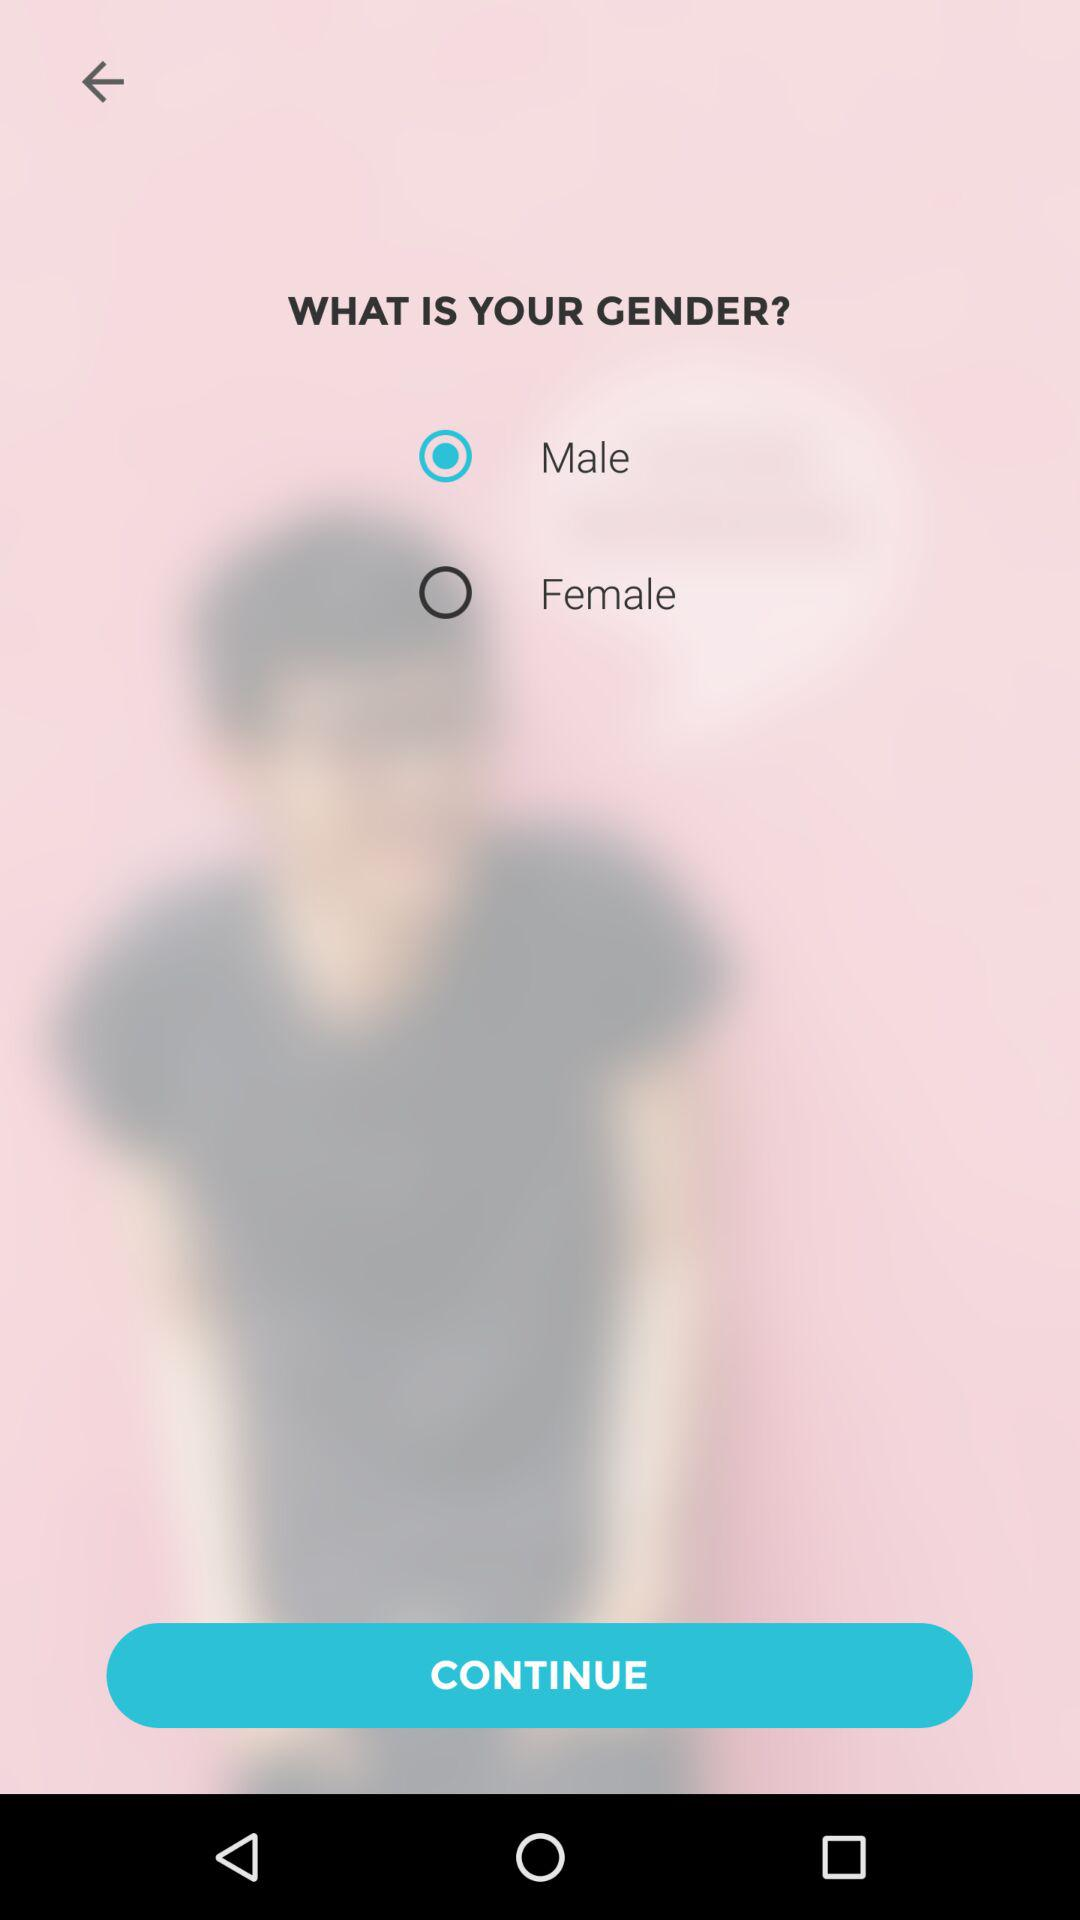Which gender is selected? The selected gender is male. 